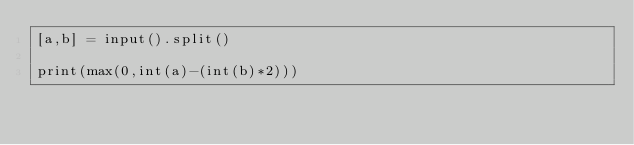Convert code to text. <code><loc_0><loc_0><loc_500><loc_500><_Python_>[a,b] = input().split()

print(max(0,int(a)-(int(b)*2)))</code> 